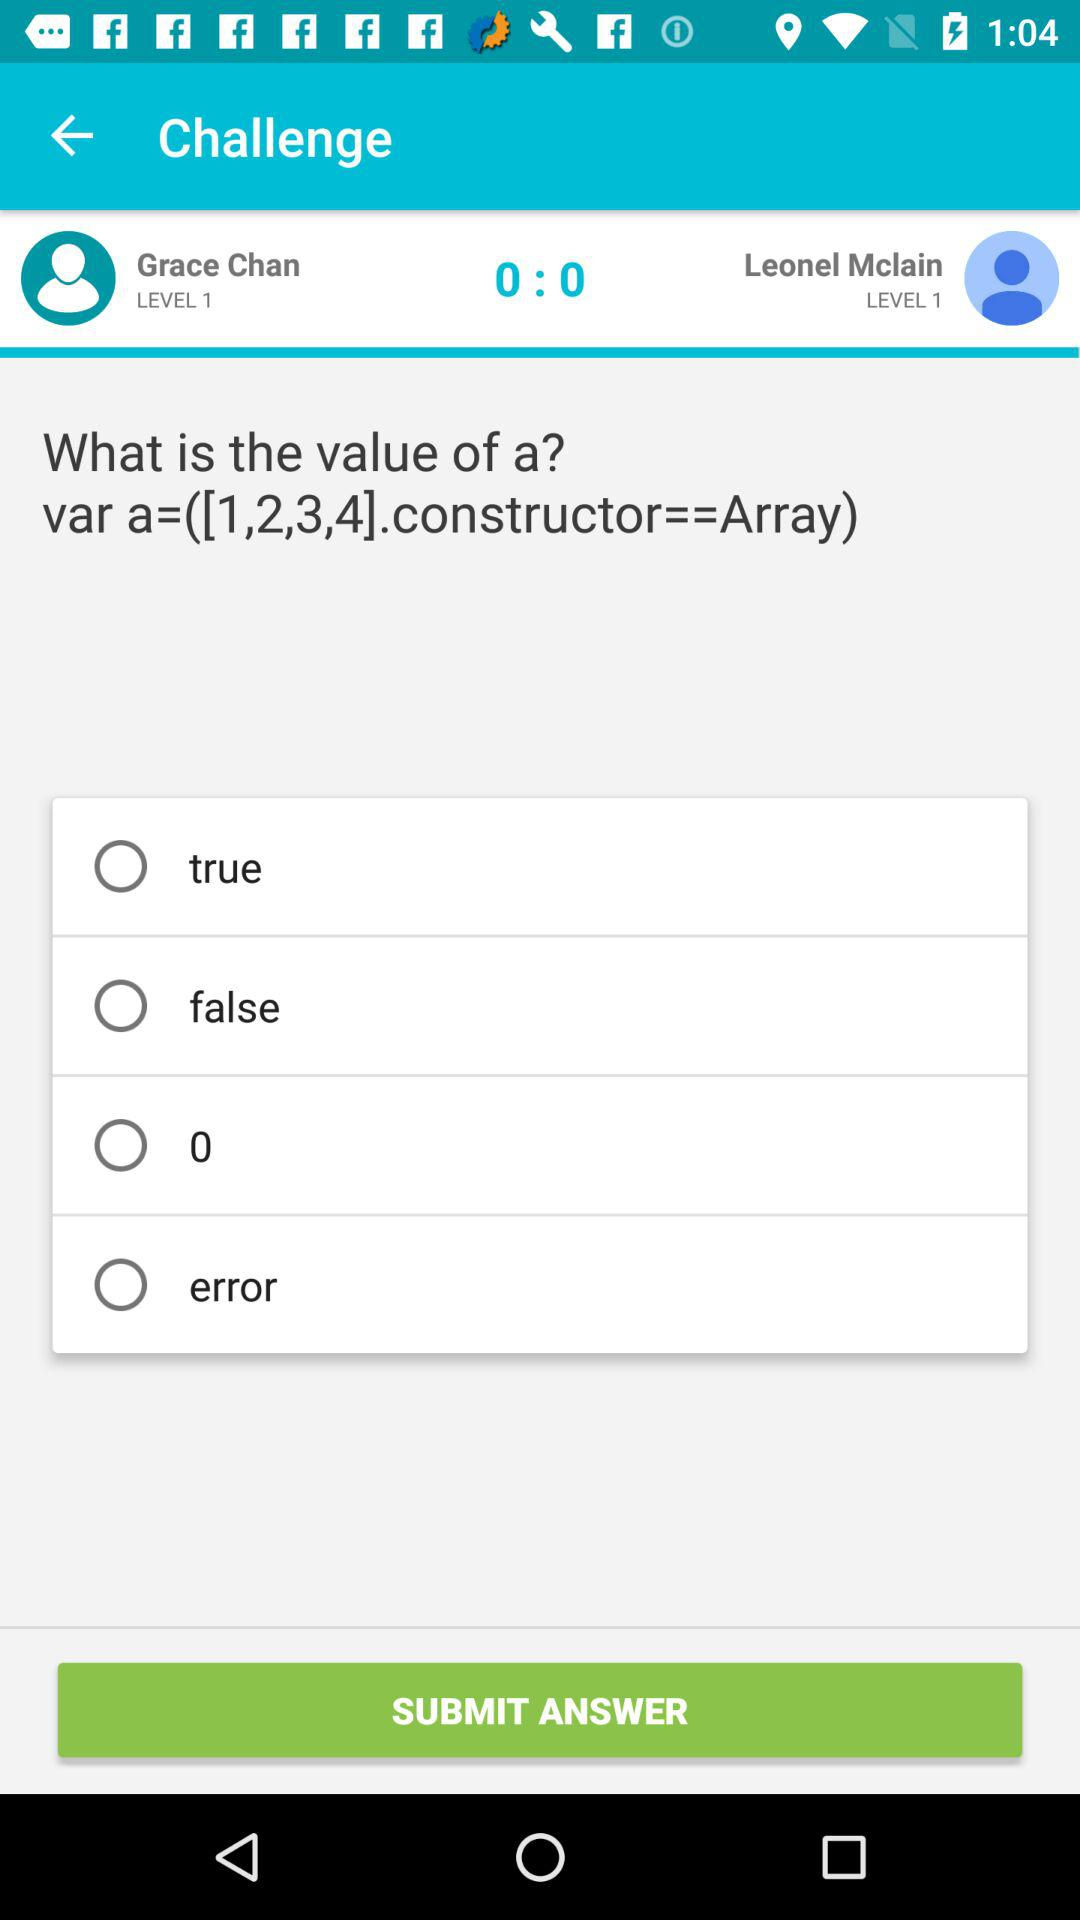Which of the following is not a valid value for a: true, false, 0, error
Answer the question using a single word or phrase. Error 